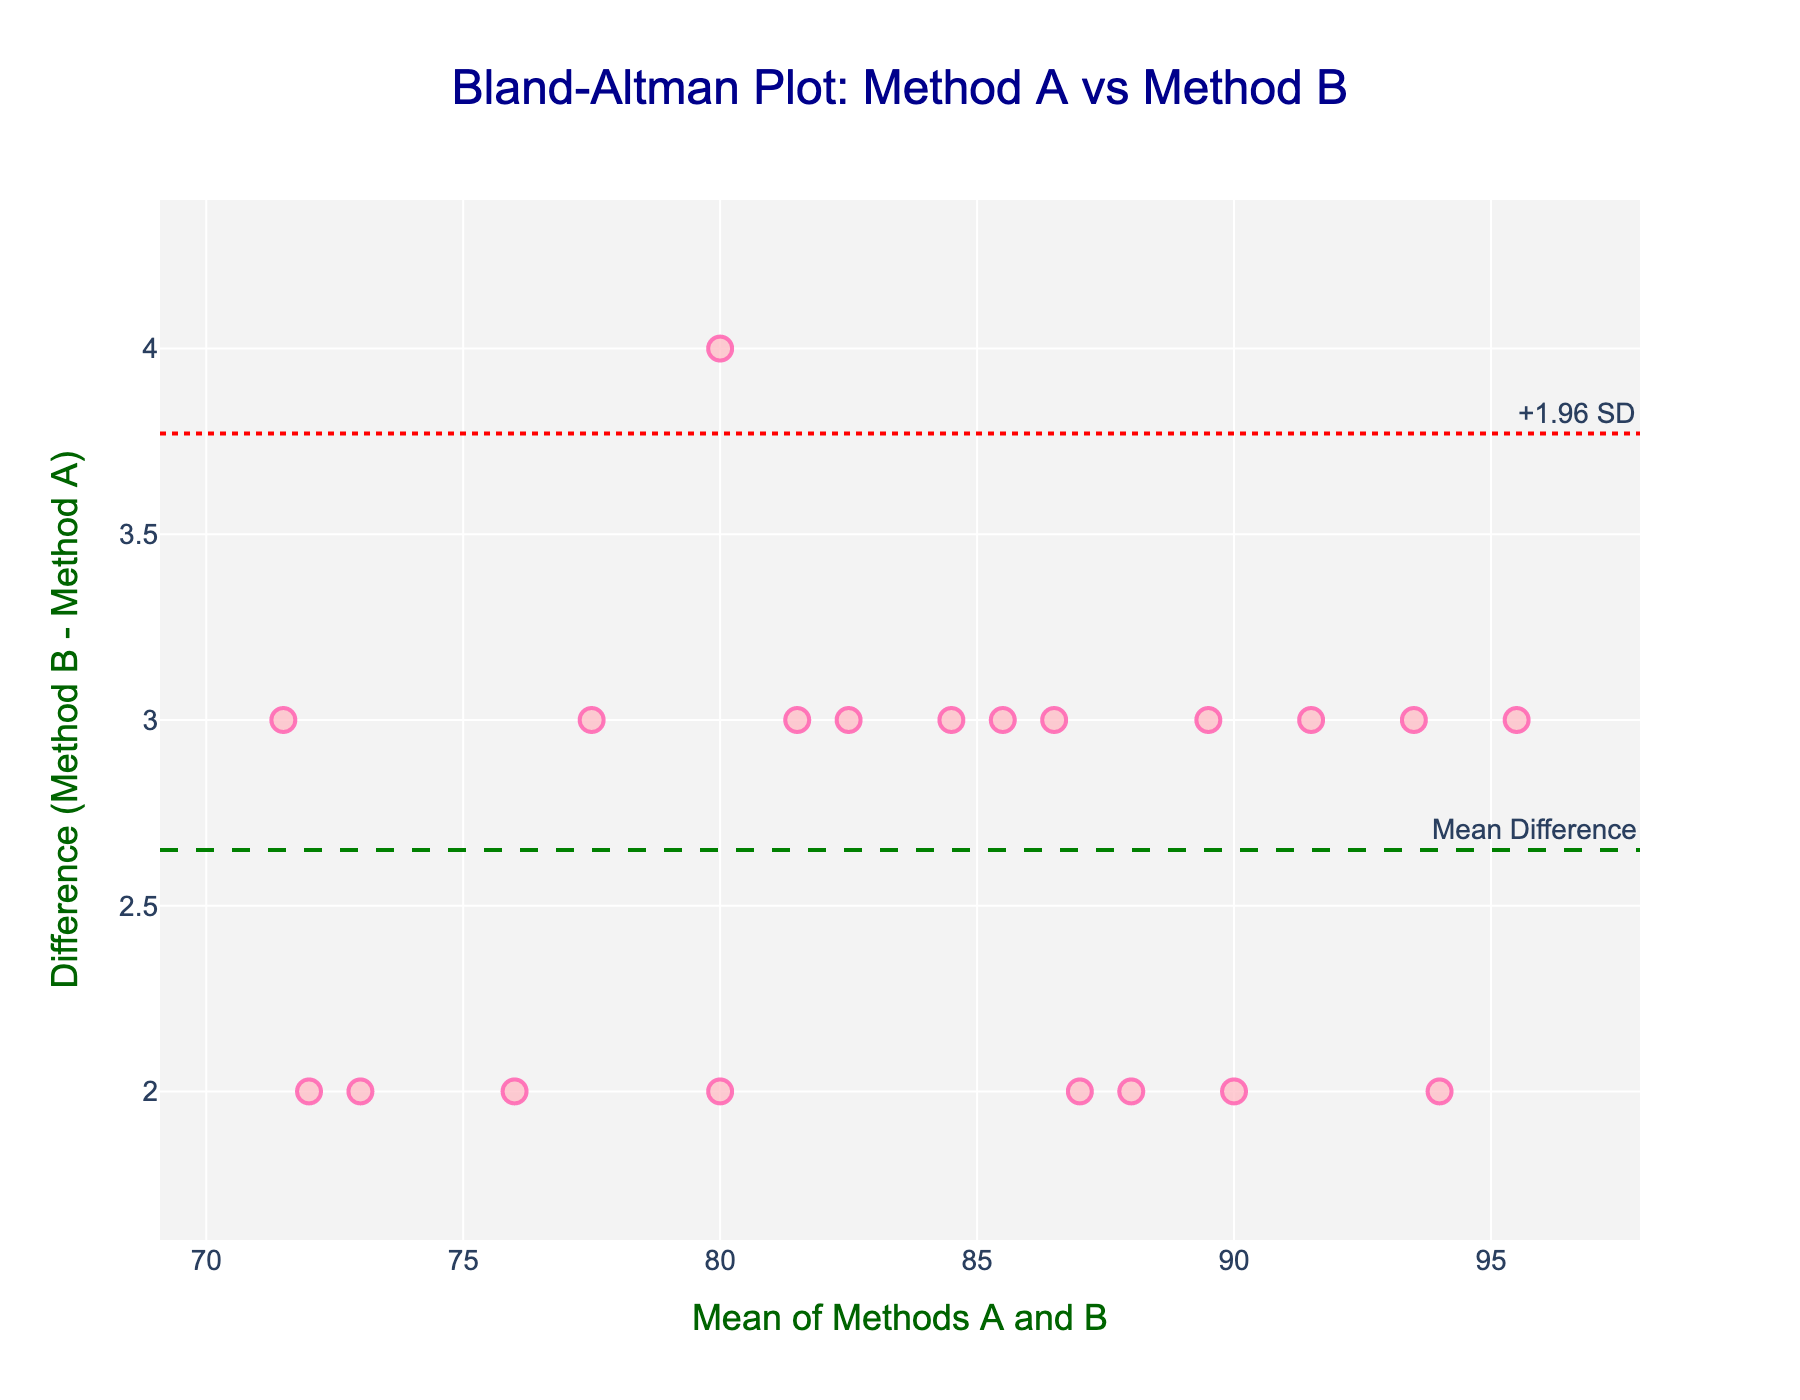what is the title of the plot? The title is usually displayed prominently at the top of the plot. In this case, it is "Bland-Altman Plot: Method A vs Method B."
Answer: Bland-Altman Plot: Method A vs Method B what do the red dotted lines represent? The red dotted lines represent the limits of agreement, which are set at ±1.96 standard deviations from the mean difference. The lines are labeled as "+1.96 SD" and "-1.96 SD."
Answer: Limits of agreement how many data points are there in the plot? Each point in the scatter plot represents a data pair from Methods A and B. By counting the points visually, you can find that there are 20 data points.
Answer: 20 what is the average of the differences between Methods A and B? The green dashed line represents the mean difference. This is labeled as "Mean Difference" on the plot. You can directly read this value from the plot, which is around 3.
Answer: Around 3 which axis represents the mean of Methods A and B? The plot usually has axis titles that describe what they represent. In this case, the x-axis is titled "Mean of Methods A and B," indicating that it represents the mean values.
Answer: X-axis are there any data points outside the limits of agreement? Limits of agreement are represented by the red dotted lines. By visually inspecting the plot, you can see that all data points fall within these lines, so there are no points outside the limits.
Answer: No what is the range of mean values on the x-axis? The x-axis range can be determined by examining the axis limits. From the plot, the minimum mean value is around 70, and the maximum is around 95.
Answer: 70 to 95 what is the mean value of the lowest data point on the plot? Identify the lowest data point on the y-axis, then look at its corresponding mean value on the x-axis. The lowest data point (difference around 2) corresponds to a mean value close to 72.
Answer: Around 72 which data point has the highest difference value? The highest difference value can be identified as the highest point on the y-axis. This data point has a difference of approximately 4.7 and a mean value close to 93.
Answer: Difference value of around 4.7 how can you determine if the two methods are consistent? Consistency can be interpreted from the Bland-Altman plot by checking whether most data points lie within the limits of agreement and how close the differences are to the mean difference.
Answer: Most points within the limits of agreement with differences close to mean 